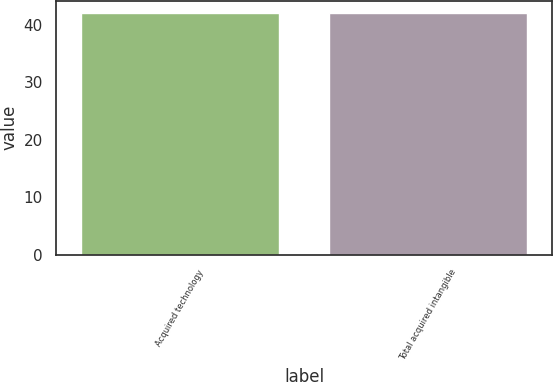Convert chart to OTSL. <chart><loc_0><loc_0><loc_500><loc_500><bar_chart><fcel>Acquired technology<fcel>Total acquired intangible<nl><fcel>42<fcel>42.1<nl></chart> 